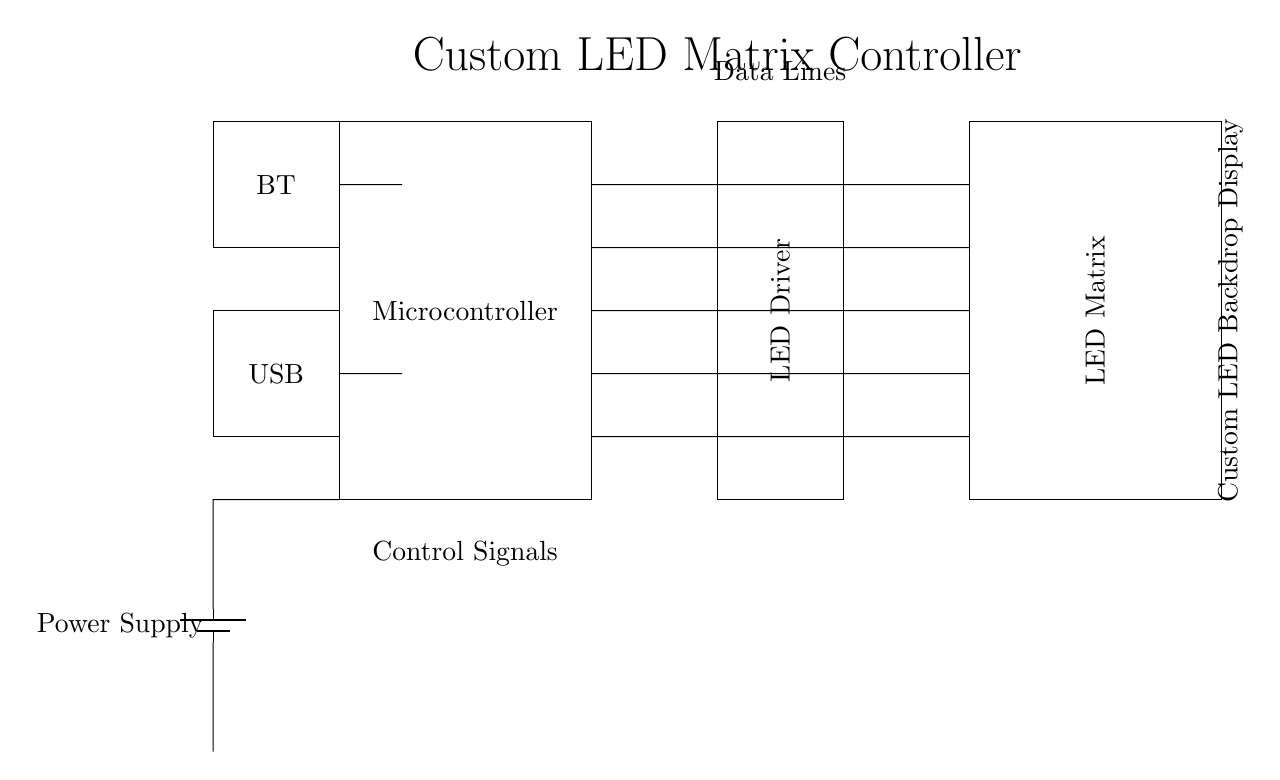What is the main component used for controlling the LED matrix? The main component is the Microcontroller, as labeled in the diagram, which serves as the central unit for managing the LED matrix operations.
Answer: Microcontroller How many data lines are connected between the microcontroller and the LED matrix? There are five data lines illustrated by the connections between the microcontroller and the LED matrix. The lines are drawn parallel to each other at different heights, showing a direct relationship for sending signals.
Answer: Five What does the Bluetooth module connect to? The Bluetooth module connects to the Microcontroller, allowing for wireless control or data transfer. The diagram shows a direct line connection from the BT box to the microcontroller.
Answer: Microcontroller What is the purpose of the USB interface in this circuit? The USB interface is designed for data communication and possibly programming the microcontroller. The diagram indicates that it connects directly to the microcontroller, suggesting its role in external communication.
Answer: Data communication Which component is responsible for driving the LEDs? The LED Driver is tasked with providing the necessary power and signal to the LED matrix, as depicted in the diagram with a direct connection to the LED matrix.
Answer: LED Driver Explain the role of the Power Supply in the circuit. The Power Supply provides voltage to the circuit. It connects to the microcontroller and possibly the LED Driver, supplying the necessary energy for the components to function effectively. It’s essential for keeping the entire circuit operational.
Answer: Supplies voltage 